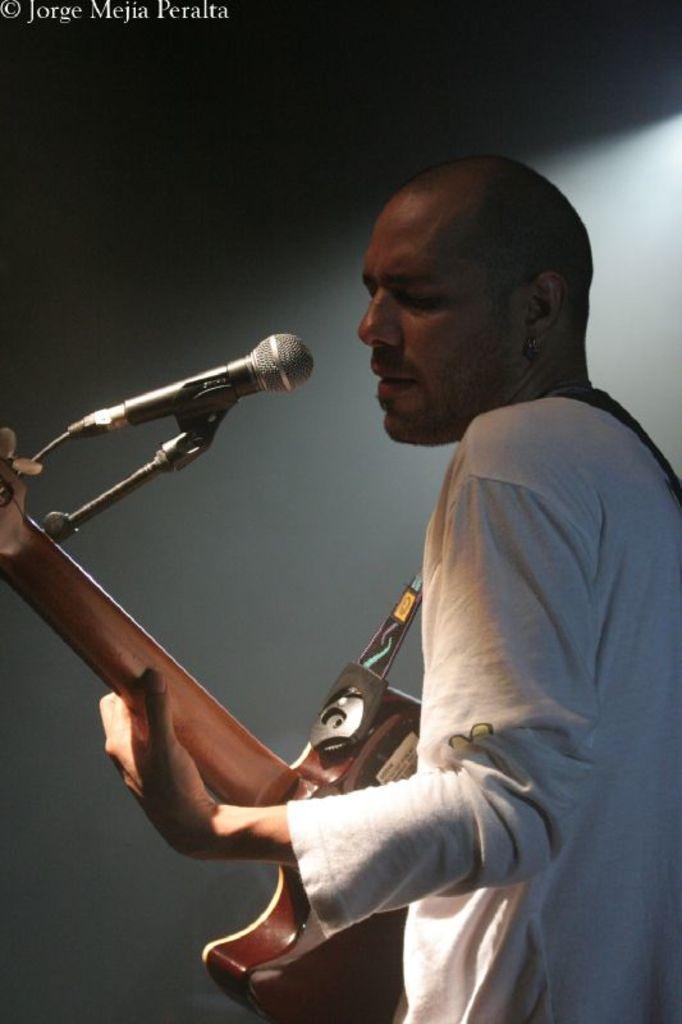Could you give a brief overview of what you see in this image? In this image we can see a person playing a guitar. Also there is a mic with mic stand. At the top there is watermark. 